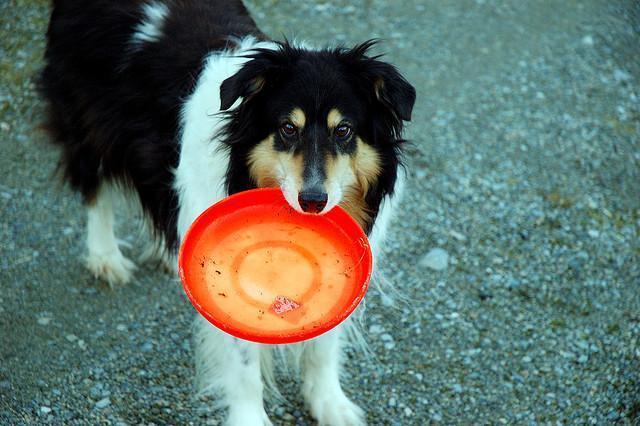How many pieces is the sandwich cut into?
Give a very brief answer. 0. 